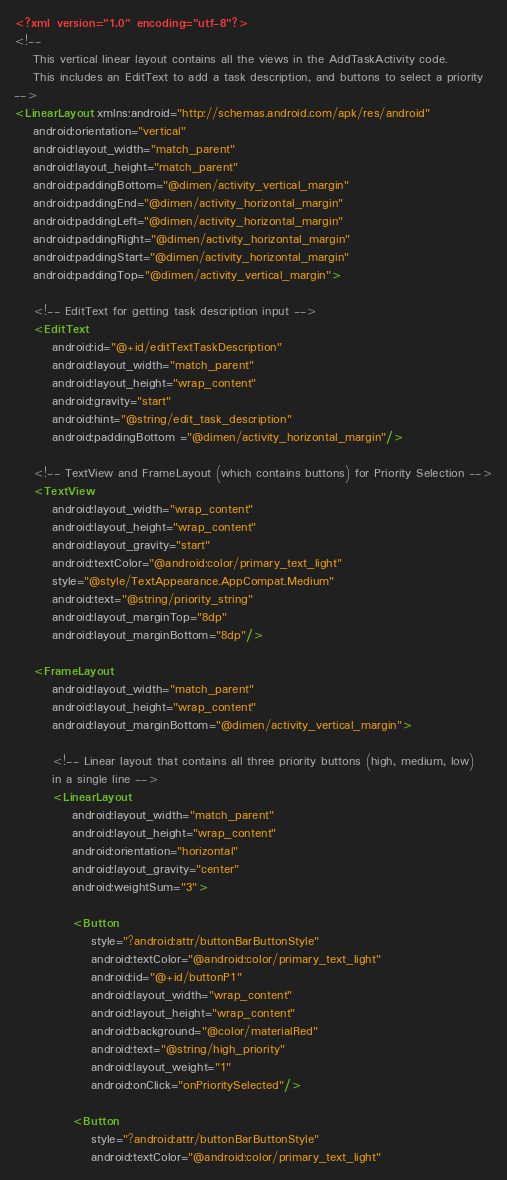Convert code to text. <code><loc_0><loc_0><loc_500><loc_500><_XML_><?xml version="1.0" encoding="utf-8"?>
<!--
    This vertical linear layout contains all the views in the AddTaskActivity code.
    This includes an EditText to add a task description, and buttons to select a priority
-->
<LinearLayout xmlns:android="http://schemas.android.com/apk/res/android"
    android:orientation="vertical"
    android:layout_width="match_parent"
    android:layout_height="match_parent"
    android:paddingBottom="@dimen/activity_vertical_margin"
    android:paddingEnd="@dimen/activity_horizontal_margin"
    android:paddingLeft="@dimen/activity_horizontal_margin"
    android:paddingRight="@dimen/activity_horizontal_margin"
    android:paddingStart="@dimen/activity_horizontal_margin"
    android:paddingTop="@dimen/activity_vertical_margin">

    <!-- EditText for getting task description input -->
    <EditText
        android:id="@+id/editTextTaskDescription"
        android:layout_width="match_parent"
        android:layout_height="wrap_content"
        android:gravity="start"
        android:hint="@string/edit_task_description"
        android:paddingBottom ="@dimen/activity_horizontal_margin"/>

    <!-- TextView and FrameLayout (which contains buttons) for Priority Selection -->
    <TextView
        android:layout_width="wrap_content"
        android:layout_height="wrap_content"
        android:layout_gravity="start"
        android:textColor="@android:color/primary_text_light"
        style="@style/TextAppearance.AppCompat.Medium"
        android:text="@string/priority_string"
        android:layout_marginTop="8dp"
        android:layout_marginBottom="8dp"/>

    <FrameLayout
        android:layout_width="match_parent"
        android:layout_height="wrap_content"
        android:layout_marginBottom="@dimen/activity_vertical_margin">

        <!-- Linear layout that contains all three priority buttons (high, medium, low)
        in a single line -->
        <LinearLayout
            android:layout_width="match_parent"
            android:layout_height="wrap_content"
            android:orientation="horizontal"
            android:layout_gravity="center"
            android:weightSum="3">

            <Button
                style="?android:attr/buttonBarButtonStyle"
                android:textColor="@android:color/primary_text_light"
                android:id="@+id/buttonP1"
                android:layout_width="wrap_content"
                android:layout_height="wrap_content"
                android:background="@color/materialRed"
                android:text="@string/high_priority"
                android:layout_weight="1"
                android:onClick="onPrioritySelected"/>

            <Button
                style="?android:attr/buttonBarButtonStyle"
                android:textColor="@android:color/primary_text_light"</code> 